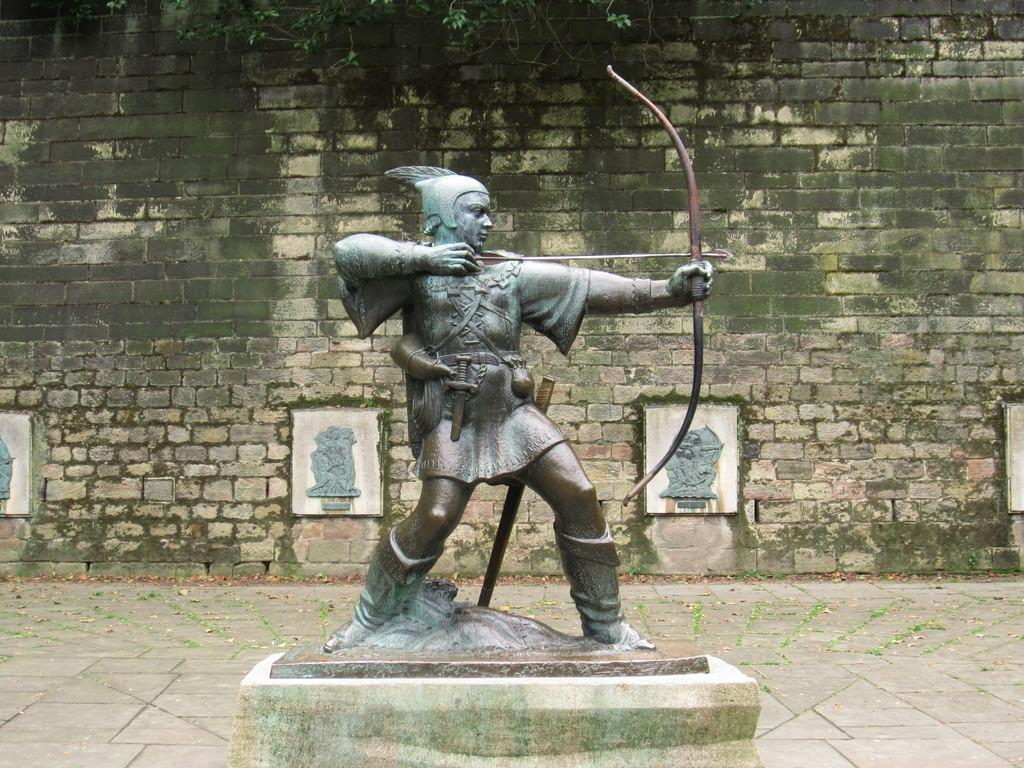What is the main subject in the image? There is a statue in the image. What is located at the bottom of the image? There is a path at the bottom of the image. What can be seen in the background of the image? There are sculptures, a wall, leaves, and stems visible in the background of the image. How does the statue drop leaves in the image? The statue does not drop leaves in the image; it is a stationary object. 